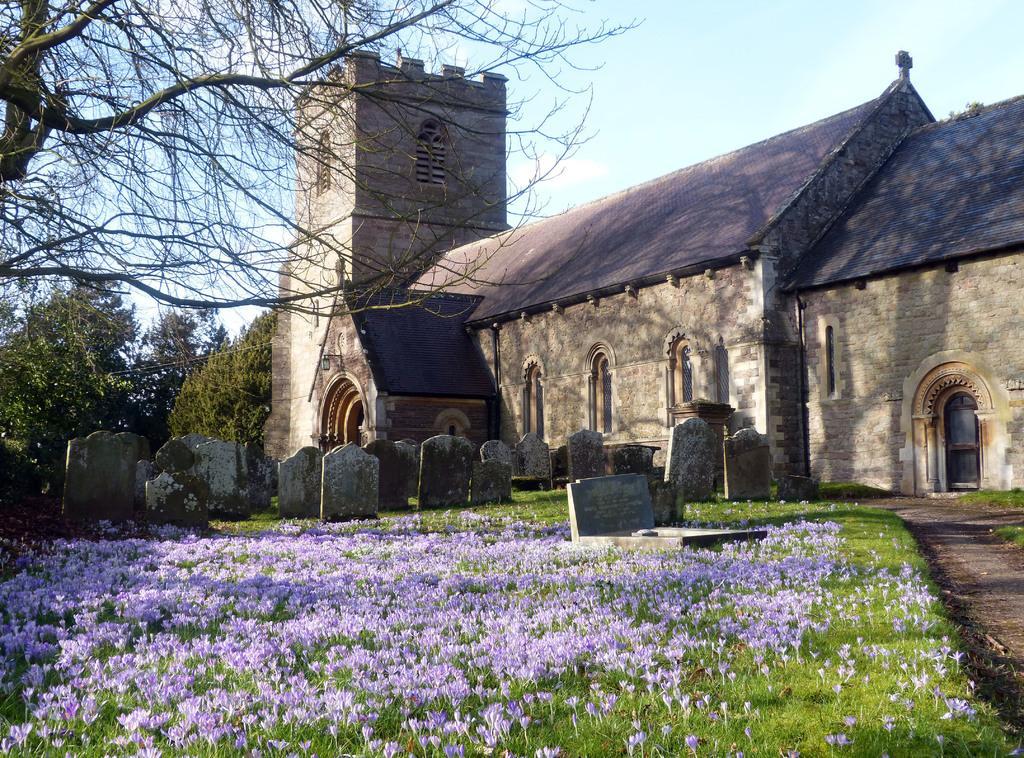Describe this image in one or two sentences. In this image I can see few houses, windows, trees, few purple color flowers and few tombstones. The sky is in blue and white color. 